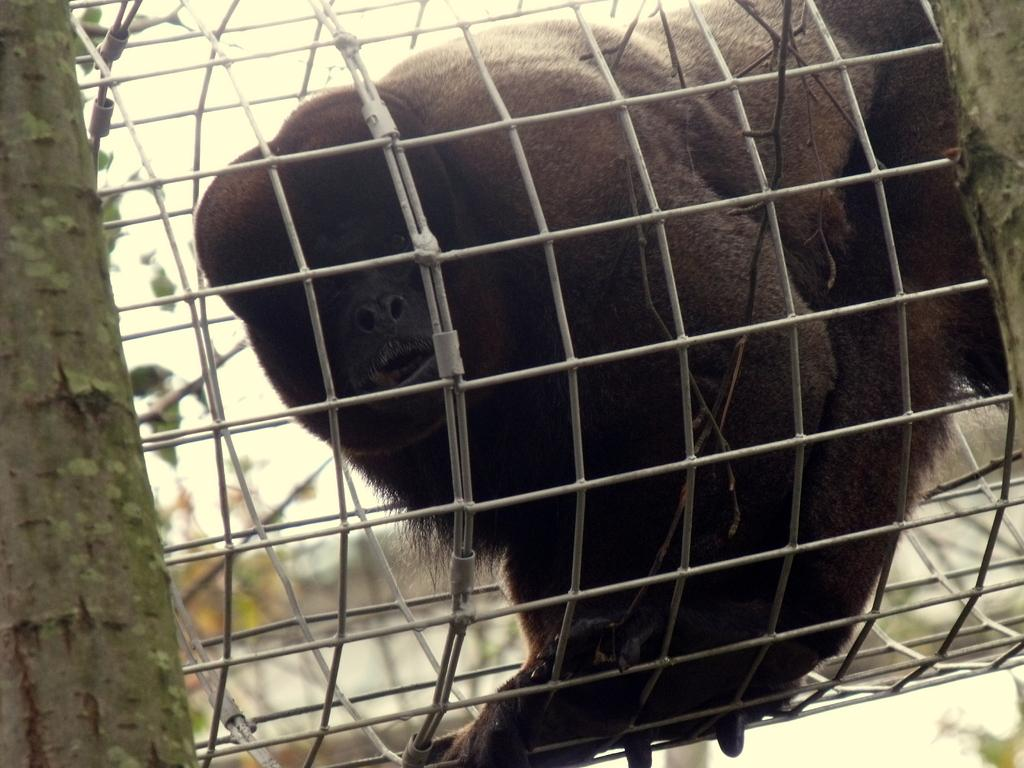What type of animal is in the image? There is a chimpanzee in the image. Where is the chimpanzee located? The chimpanzee is in a cage. What can be seen in the background of the image? There are trees visible in the image. What type of ring can be seen on the chimpanzee's finger in the image? There is no ring visible on the chimpanzee's finger in the image. What season is depicted in the image? The provided facts do not mention any season, so it cannot be determined from the image. 